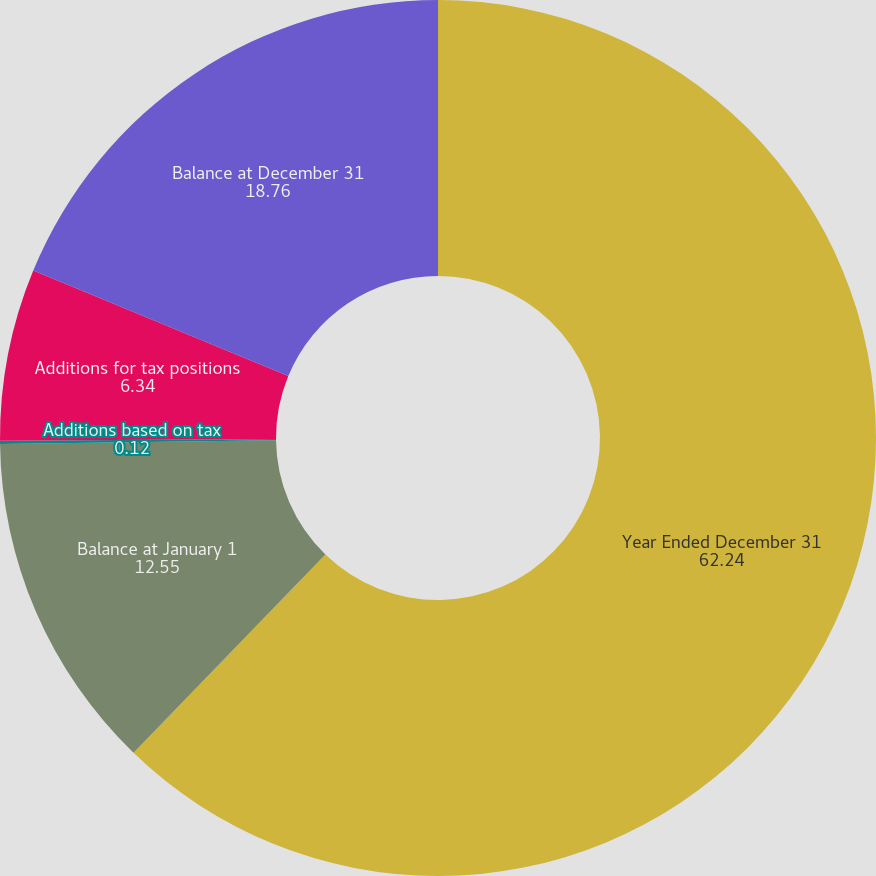<chart> <loc_0><loc_0><loc_500><loc_500><pie_chart><fcel>Year Ended December 31<fcel>Balance at January 1<fcel>Additions based on tax<fcel>Additions for tax positions<fcel>Balance at December 31<nl><fcel>62.24%<fcel>12.55%<fcel>0.12%<fcel>6.34%<fcel>18.76%<nl></chart> 